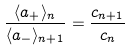<formula> <loc_0><loc_0><loc_500><loc_500>\frac { \langle a _ { + } \rangle _ { n } } { \langle a _ { - } \rangle _ { n + 1 } } & = \frac { c _ { n + 1 } } { c _ { n } }</formula> 